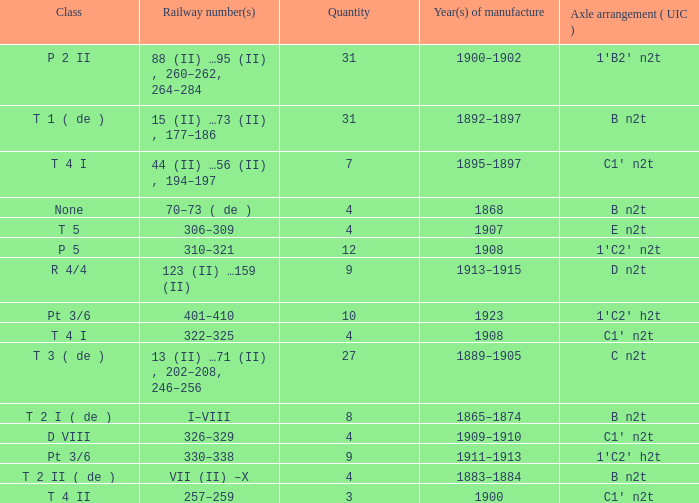When was the b n2t axle arrangement, with a total of 31, made? 1892–1897. 